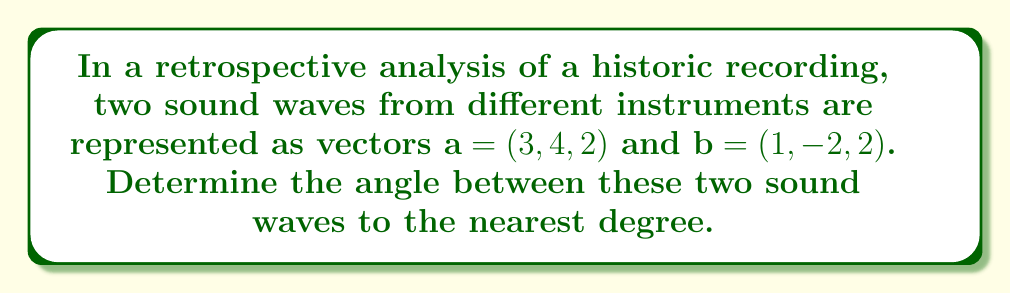Show me your answer to this math problem. To find the angle between two vectors, we can use the dot product formula:

$$\cos \theta = \frac{\mathbf{a} \cdot \mathbf{b}}{|\mathbf{a}||\mathbf{b}|}$$

Where $\mathbf{a} \cdot \mathbf{b}$ is the dot product of the vectors, and $|\mathbf{a}|$ and $|\mathbf{b}|$ are the magnitudes of the vectors.

Step 1: Calculate the dot product $\mathbf{a} \cdot \mathbf{b}$
$$\mathbf{a} \cdot \mathbf{b} = (3)(1) + (4)(-2) + (2)(2) = 3 - 8 + 4 = -1$$

Step 2: Calculate the magnitudes of the vectors
$$|\mathbf{a}| = \sqrt{3^2 + 4^2 + 2^2} = \sqrt{9 + 16 + 4} = \sqrt{29}$$
$$|\mathbf{b}| = \sqrt{1^2 + (-2)^2 + 2^2} = \sqrt{1 + 4 + 4} = 3$$

Step 3: Substitute into the formula
$$\cos \theta = \frac{-1}{\sqrt{29} \cdot 3}$$

Step 4: Calculate $\theta$ using inverse cosine
$$\theta = \arccos\left(\frac{-1}{\sqrt{29} \cdot 3}\right)$$

Step 5: Convert to degrees and round to the nearest degree
$$\theta \approx 98^\circ$$
Answer: The angle between the two sound waves is approximately 98°. 